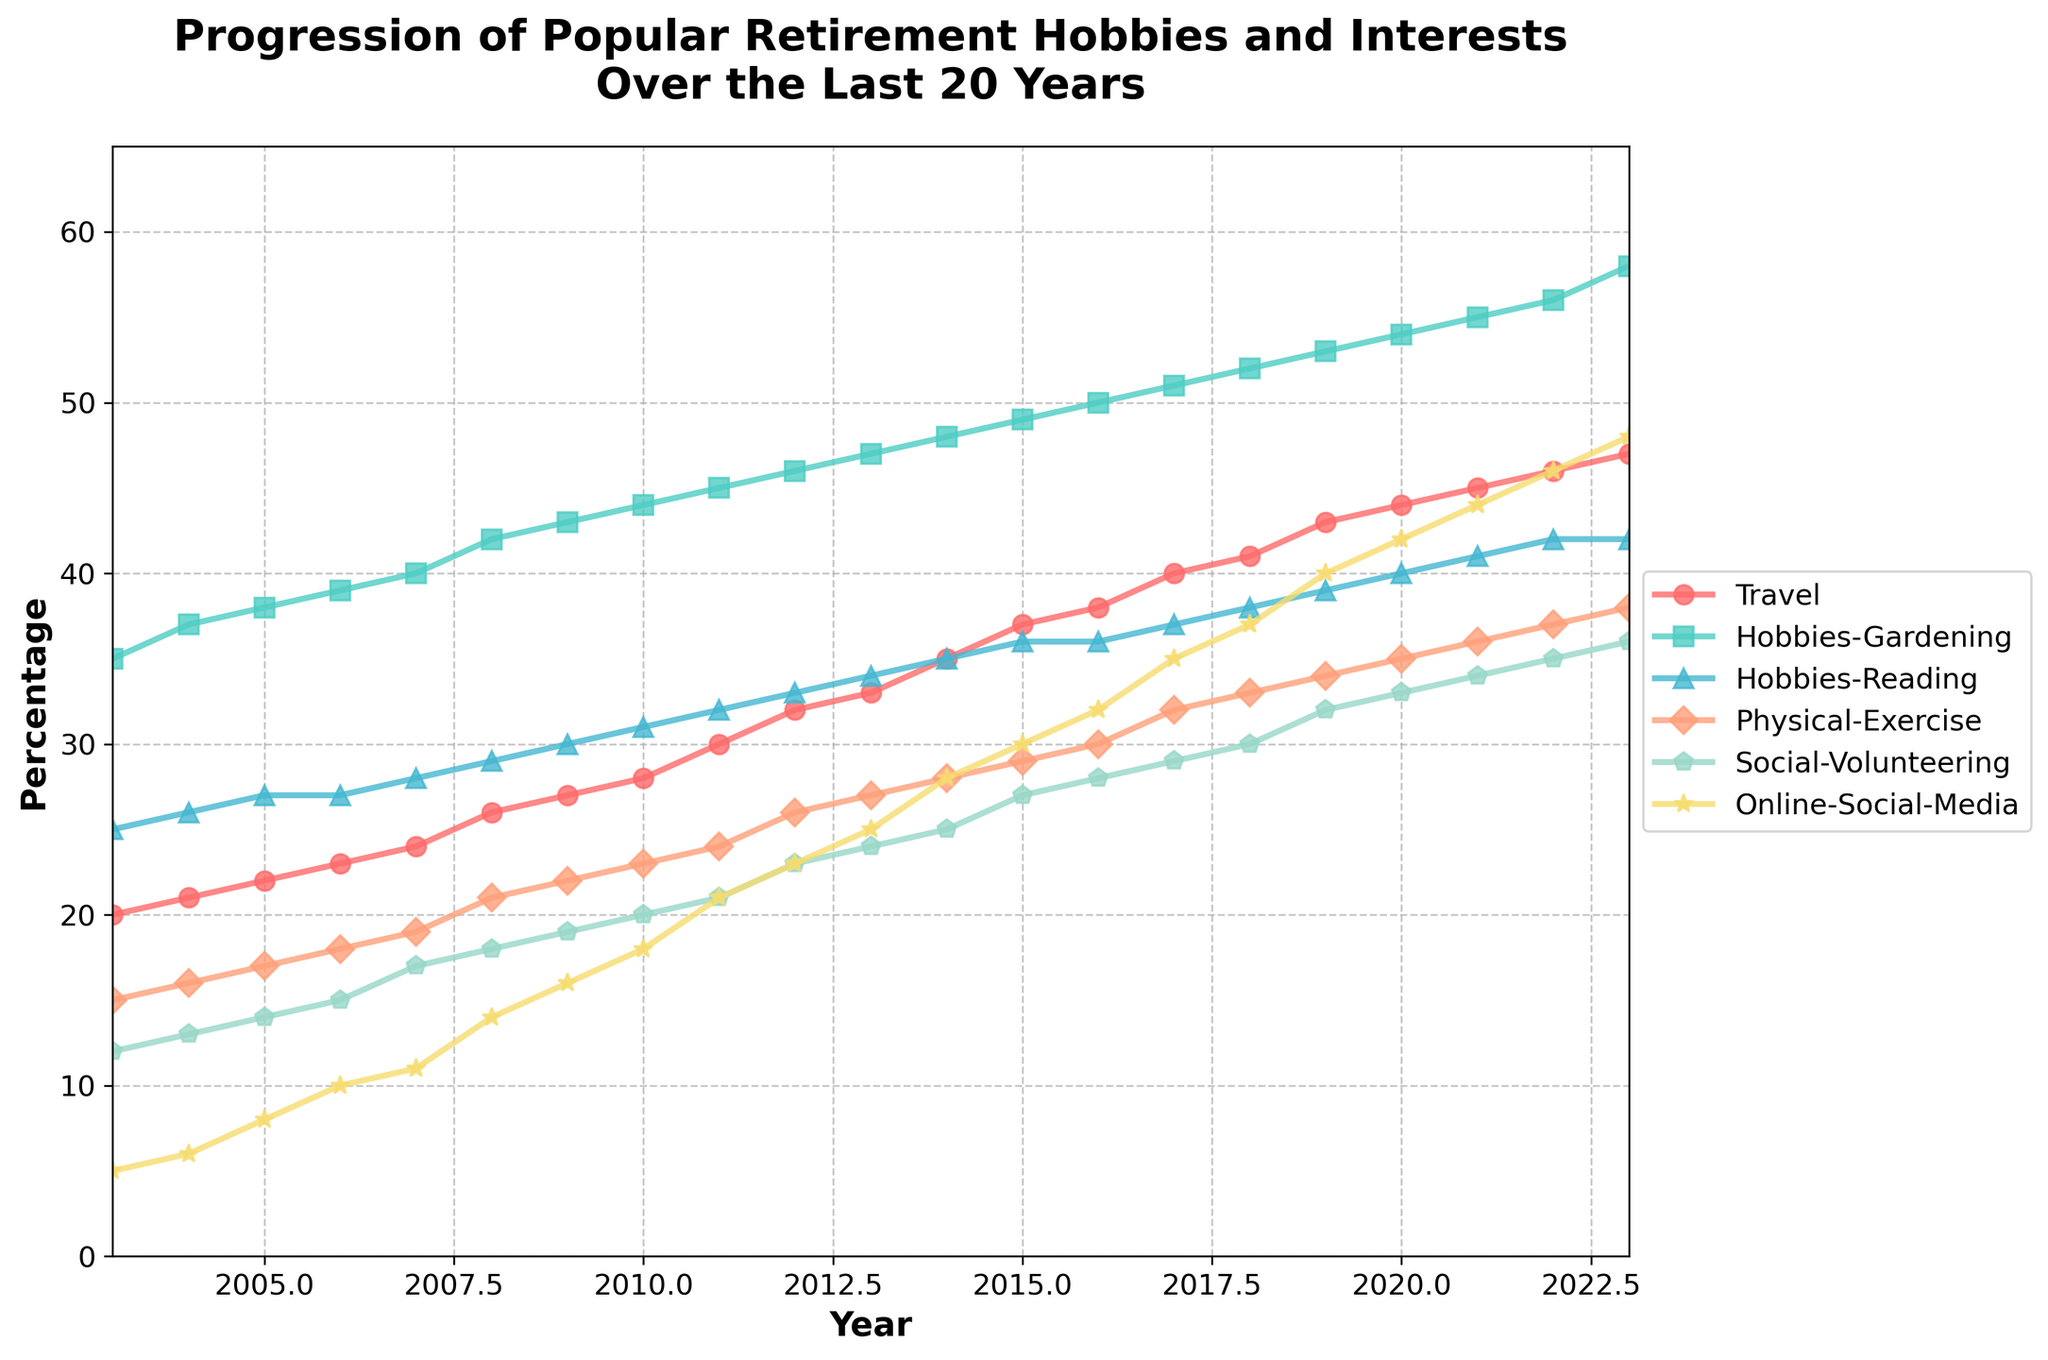what is the title of this plot? The title is usually displayed at the top of the plot and provides a brief summary of what the plot is about. The title of this plot gives an overview of the content being displayed over a period of time.
Answer: Progression of Popular Retirement Hobbies and Interests Over the Last 20 Years what are the years shown on the x-axis? The x-axis of the plot typically shows the time period over which the data has been collected. In this case, the years range from 2003 to 2023. This is visible along the horizontal axis of the plot.
Answer: 2003 to 2023 which activity showed the most significant increase over the 20-year period? To determine the activity with the most significant increase, look for the line that has the largest change in percentage values from the start year (2003) to the end year (2023). "Online-Social-Media" starts at 5% in 2003 and reaches 48% in 2023, showing a significant increase of 43%.
Answer: Online-Social-Media what percentage was "Physical-Exercise" in 2010? To find this, look for the "Physical-Exercise" line on the plot and trace it to the year 2010. The plot shows the value associated with each year. In 2010, "Physical-Exercise" is at 23%.
Answer: 23% how many data points are there for each activity? The number of data points for each activity corresponds to the number of years shown on the x-axis. Since the years range from 2003 to 2023, there are 21 data points for each activity.
Answer: 21 which two activities intersect on the plot, if any, and in what year? To determine intersections, look for points where two lines cross each other. From the plot, "Physical-Exercise" and "Hobbies-Reading" intersect around the year 2016 when both have the same percentage value of 36%.
Answer: Physical-Exercise and Hobbies-Reading in 2016 what’s the average percentage of “Travel” in the first 10 years? To find the average percentage of “Travel” over the first 10 years, calculate the mean of the values from 2003 to 2012. The values are: 20, 21, 22, 23, 24, 26, 27, 28, 30, 32. Sum these values (20+21+22+23+24+26+27+28+30+32 = 253) and divide by 10.
Answer: 25.3% what activity had the lowest popularity in 2005? To identify this, look at the percentages for each activity in 2005. The activity with the smallest value is "Online-Social-Media" at 8%.
Answer: Online-Social-Media did “Hobbies-Gardening” ever decrease over the 20-year period? To check for decrease, one must ensure all values for "Hobbies-Gardening" consistently increase or stay the same throughout the years. Observing the plot, we can see it continually increases every year.
Answer: No 